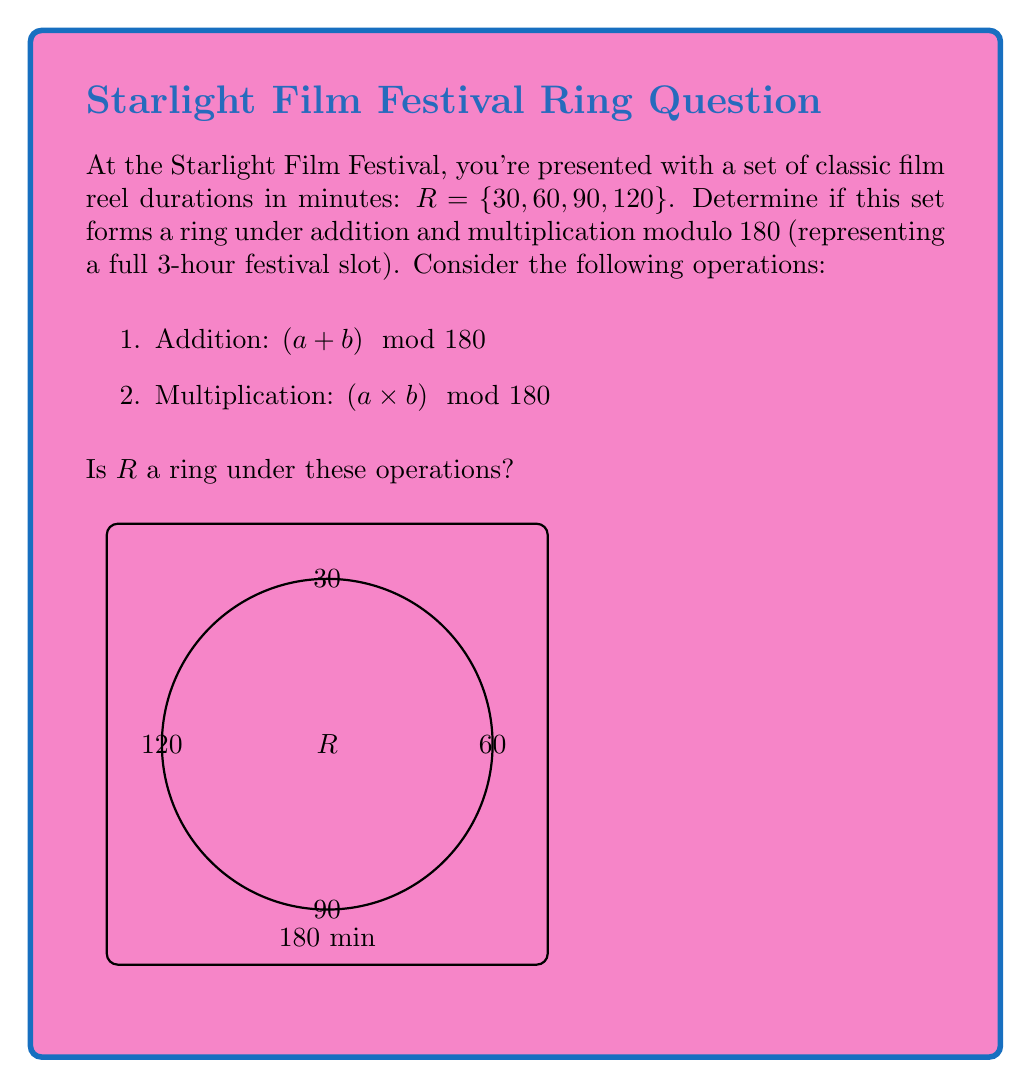Can you solve this math problem? To determine if $R$ forms a ring, we need to check if it satisfies the ring axioms under the given operations:

1. Closure under addition and multiplication:
   For all $a, b \in R$, $(a + b) \mod 180$ and $(a \times b) \mod 180$ must be in $R$.
   
   Example: $60 + 90 = 150 \mod 180 = 150$ (not in $R$)
   
   This violates closure, so $R$ is not closed under addition.

2. Associativity of addition and multiplication:
   $((a + b) + c) \mod 180 = (a + (b + c)) \mod 180$
   $((a \times b) \times c) \mod 180 = (a \times (b \times c)) \mod 180$
   
   These hold for modular arithmetic.

3. Commutativity of addition and multiplication:
   $(a + b) \mod 180 = (b + a) \mod 180$
   $(a \times b) \mod 180 = (b \times a) \mod 180$
   
   These hold for modular arithmetic.

4. Existence of additive identity:
   $0 \mod 180 = 0$, but $0 \notin R$

5. Existence of additive inverses:
   For $30$: $-30 \mod 180 = 150 \notin R$
   For $60$: $-60 \mod 180 = 120 \in R$
   For $90$: $-90 \mod 180 = 90 \in R$
   For $120$: $-120 \mod 180 = 60 \in R$
   
   Not all elements have additive inverses in $R$.

6. Distributivity:
   $a \times (b + c) \mod 180 = ((a \times b) + (a \times c)) \mod 180$
   
   This holds for modular arithmetic.

Since $R$ fails to satisfy closure under addition, lacks an additive identity, and doesn't have additive inverses for all elements, it does not form a ring under the given operations.
Answer: No, $R$ is not a ring. 